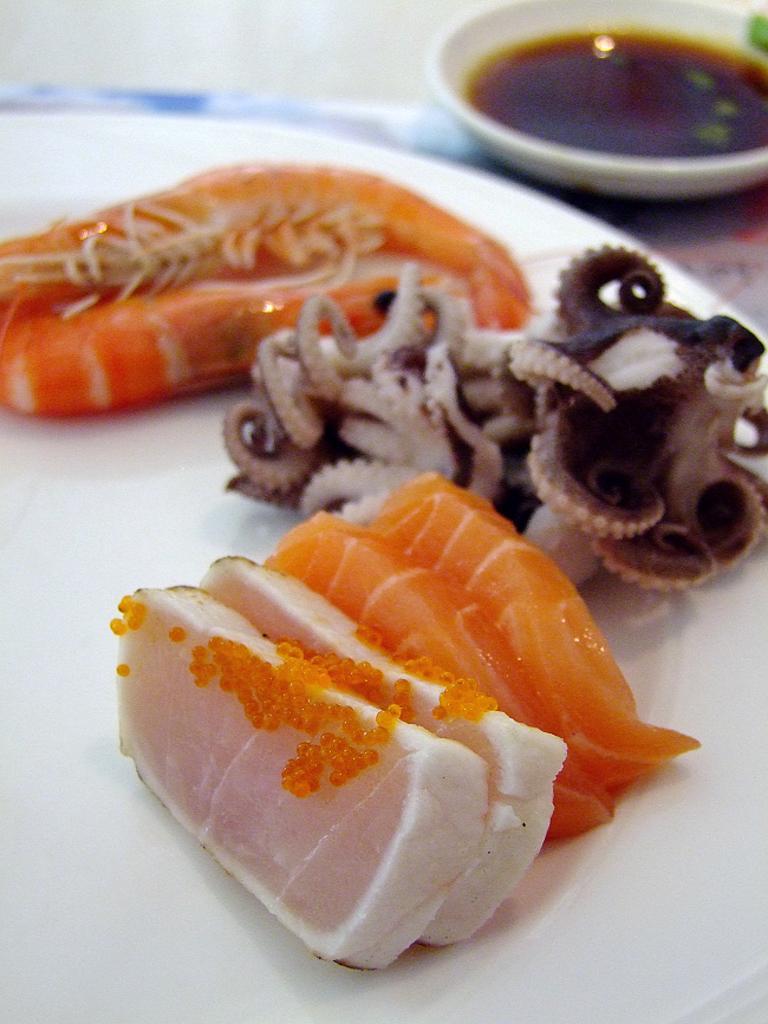In one or two sentences, can you explain what this image depicts? In the picture I can see the raw meat items on the plate. I can see a dish bowl on the top right side of the picture. 